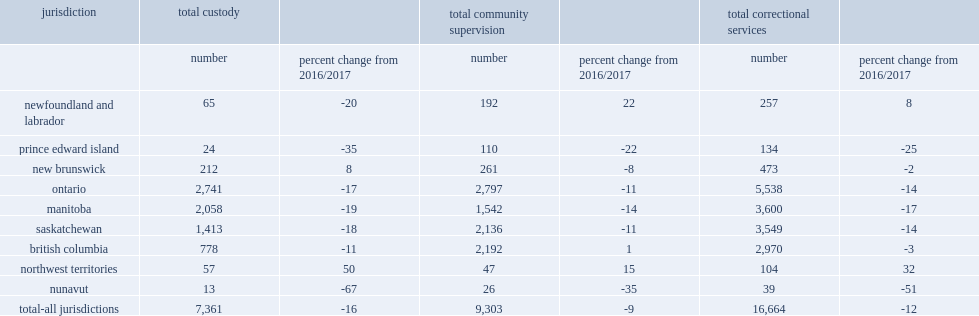In 2017/2018, what is the number of youth admissions to correctional services among the nine reporting jurisdictions? 16664.0. What was the declines in the number of youth admissions to correctional services among the nine reporting jurisdictions compared to 2016/2017? 12. What was the declines in admissions to community supervision among the nine reporting jurisdictions from 2016/2017? 9. What was the declines in admissions to custody among the nine reporting jurisdictions from 2016/2017? 16. What was the declines in the number of admissions to correctional services in manitoba compared to 2016/2017? 17. What was the declines in the number of admissions to correctional services in prince edward island compared to 2016/2017? 14. What was the declines in the number of admissions to correctional services in prince edward island compared to 2016/2017? 25. What was the declines in the number of admissions to correctional services in ontario compared to 2016/2017? 14. What was the declines in total admissions in nunavut from 2016/2017? 51. What was the change in total admissions in northwest territories from 2016/2017? 32.0. 